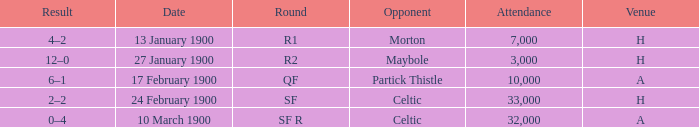What round did the celtic played away on 24 february 1900? SF. 